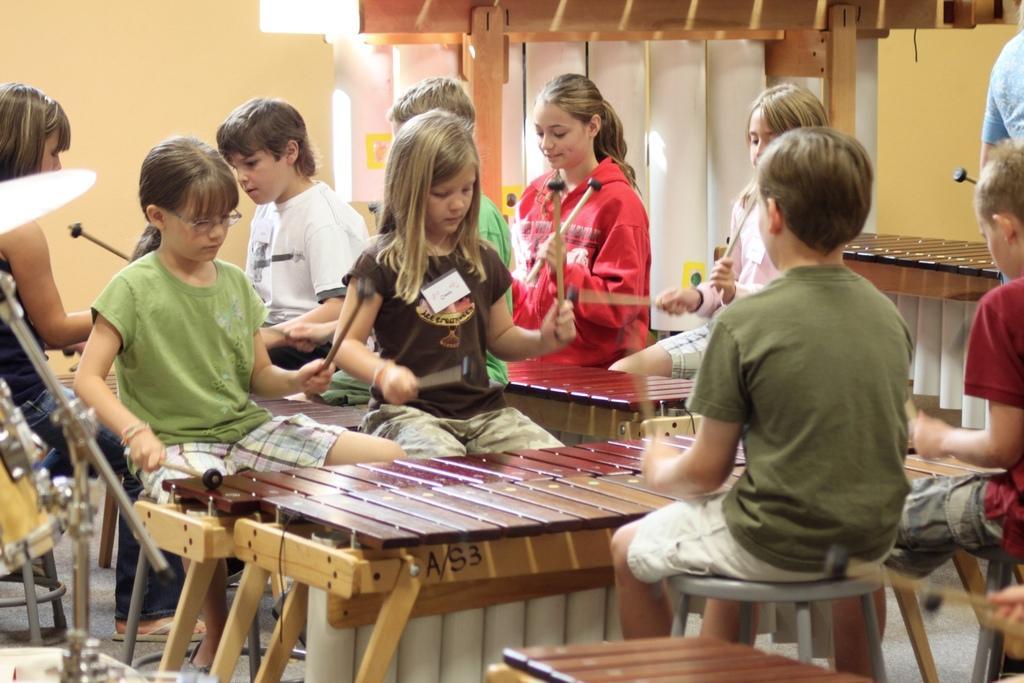How would you summarize this image in a sentence or two? In this picture many kids are playing with a tool in their hand. There is a brown table on which kids are tapping brown boxes , AS 3 is written on the table. There are also few musical instruments to the left of the image. A white curtain is attached to the brown wooden stand. 